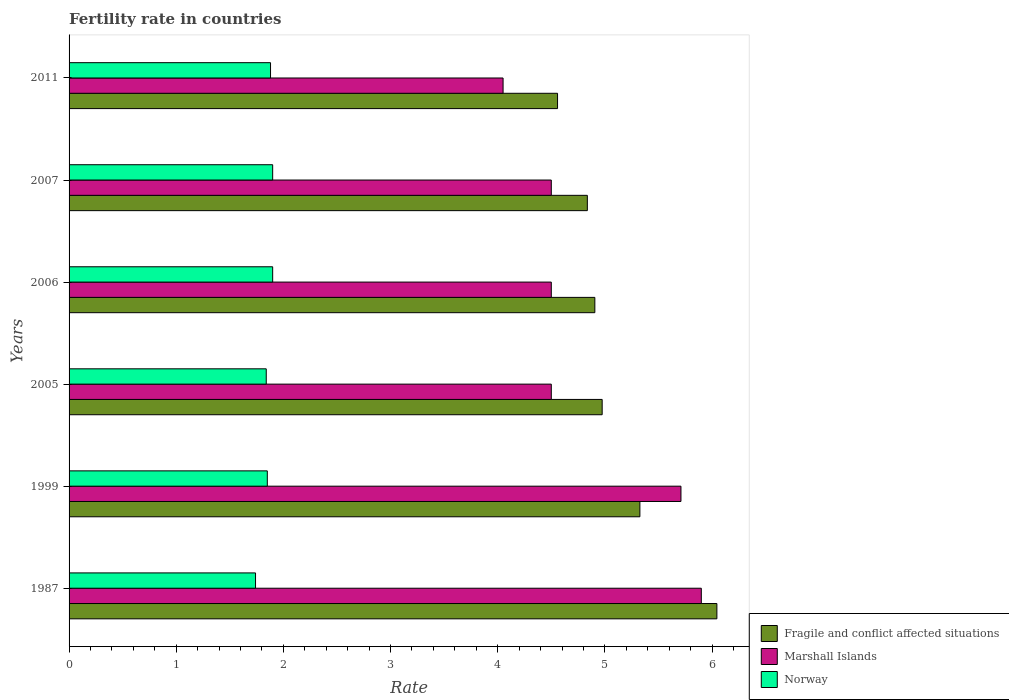How many different coloured bars are there?
Keep it short and to the point. 3. How many bars are there on the 4th tick from the bottom?
Offer a very short reply. 3. What is the label of the 3rd group of bars from the top?
Give a very brief answer. 2006. What is the fertility rate in Fragile and conflict affected situations in 2011?
Keep it short and to the point. 4.56. Across all years, what is the maximum fertility rate in Fragile and conflict affected situations?
Give a very brief answer. 6.05. Across all years, what is the minimum fertility rate in Norway?
Your answer should be very brief. 1.74. In which year was the fertility rate in Fragile and conflict affected situations maximum?
Your response must be concise. 1987. In which year was the fertility rate in Fragile and conflict affected situations minimum?
Your response must be concise. 2011. What is the total fertility rate in Norway in the graph?
Provide a succinct answer. 11.11. What is the difference between the fertility rate in Marshall Islands in 1999 and that in 2005?
Offer a very short reply. 1.21. What is the difference between the fertility rate in Norway in 2006 and the fertility rate in Marshall Islands in 2011?
Give a very brief answer. -2.15. What is the average fertility rate in Fragile and conflict affected situations per year?
Your answer should be compact. 5.11. In the year 2005, what is the difference between the fertility rate in Norway and fertility rate in Marshall Islands?
Offer a terse response. -2.66. In how many years, is the fertility rate in Marshall Islands greater than 0.4 ?
Offer a terse response. 6. What is the ratio of the fertility rate in Fragile and conflict affected situations in 1987 to that in 2011?
Ensure brevity in your answer.  1.33. Is the difference between the fertility rate in Norway in 1987 and 2007 greater than the difference between the fertility rate in Marshall Islands in 1987 and 2007?
Provide a succinct answer. No. What is the difference between the highest and the second highest fertility rate in Marshall Islands?
Your answer should be compact. 0.19. What is the difference between the highest and the lowest fertility rate in Marshall Islands?
Make the answer very short. 1.85. In how many years, is the fertility rate in Fragile and conflict affected situations greater than the average fertility rate in Fragile and conflict affected situations taken over all years?
Offer a terse response. 2. What does the 3rd bar from the top in 1999 represents?
Offer a terse response. Fragile and conflict affected situations. What does the 2nd bar from the bottom in 2006 represents?
Provide a short and direct response. Marshall Islands. How many bars are there?
Your answer should be compact. 18. How many years are there in the graph?
Offer a terse response. 6. What is the difference between two consecutive major ticks on the X-axis?
Your answer should be very brief. 1. Are the values on the major ticks of X-axis written in scientific E-notation?
Offer a terse response. No. Does the graph contain grids?
Keep it short and to the point. No. What is the title of the graph?
Keep it short and to the point. Fertility rate in countries. Does "Ireland" appear as one of the legend labels in the graph?
Give a very brief answer. No. What is the label or title of the X-axis?
Ensure brevity in your answer.  Rate. What is the label or title of the Y-axis?
Ensure brevity in your answer.  Years. What is the Rate in Fragile and conflict affected situations in 1987?
Your response must be concise. 6.05. What is the Rate of Marshall Islands in 1987?
Keep it short and to the point. 5.9. What is the Rate of Norway in 1987?
Make the answer very short. 1.74. What is the Rate in Fragile and conflict affected situations in 1999?
Make the answer very short. 5.33. What is the Rate in Marshall Islands in 1999?
Give a very brief answer. 5.71. What is the Rate of Norway in 1999?
Your answer should be very brief. 1.85. What is the Rate of Fragile and conflict affected situations in 2005?
Provide a short and direct response. 4.97. What is the Rate in Marshall Islands in 2005?
Give a very brief answer. 4.5. What is the Rate in Norway in 2005?
Your answer should be compact. 1.84. What is the Rate in Fragile and conflict affected situations in 2006?
Your answer should be very brief. 4.91. What is the Rate in Norway in 2006?
Make the answer very short. 1.9. What is the Rate in Fragile and conflict affected situations in 2007?
Offer a very short reply. 4.84. What is the Rate in Marshall Islands in 2007?
Offer a very short reply. 4.5. What is the Rate in Norway in 2007?
Your answer should be compact. 1.9. What is the Rate of Fragile and conflict affected situations in 2011?
Offer a very short reply. 4.56. What is the Rate in Marshall Islands in 2011?
Your response must be concise. 4.05. What is the Rate of Norway in 2011?
Keep it short and to the point. 1.88. Across all years, what is the maximum Rate in Fragile and conflict affected situations?
Provide a succinct answer. 6.05. Across all years, what is the minimum Rate in Fragile and conflict affected situations?
Give a very brief answer. 4.56. Across all years, what is the minimum Rate of Marshall Islands?
Provide a short and direct response. 4.05. Across all years, what is the minimum Rate in Norway?
Your answer should be compact. 1.74. What is the total Rate in Fragile and conflict affected situations in the graph?
Your response must be concise. 30.65. What is the total Rate of Marshall Islands in the graph?
Offer a terse response. 29.16. What is the total Rate in Norway in the graph?
Make the answer very short. 11.11. What is the difference between the Rate of Fragile and conflict affected situations in 1987 and that in 1999?
Your response must be concise. 0.72. What is the difference between the Rate in Marshall Islands in 1987 and that in 1999?
Your answer should be very brief. 0.19. What is the difference between the Rate of Norway in 1987 and that in 1999?
Your answer should be compact. -0.11. What is the difference between the Rate in Fragile and conflict affected situations in 1987 and that in 2005?
Make the answer very short. 1.07. What is the difference between the Rate of Fragile and conflict affected situations in 1987 and that in 2006?
Offer a very short reply. 1.14. What is the difference between the Rate in Norway in 1987 and that in 2006?
Offer a terse response. -0.16. What is the difference between the Rate in Fragile and conflict affected situations in 1987 and that in 2007?
Your answer should be compact. 1.21. What is the difference between the Rate of Marshall Islands in 1987 and that in 2007?
Your answer should be very brief. 1.4. What is the difference between the Rate of Norway in 1987 and that in 2007?
Make the answer very short. -0.16. What is the difference between the Rate of Fragile and conflict affected situations in 1987 and that in 2011?
Your answer should be compact. 1.49. What is the difference between the Rate in Marshall Islands in 1987 and that in 2011?
Provide a short and direct response. 1.85. What is the difference between the Rate in Norway in 1987 and that in 2011?
Make the answer very short. -0.14. What is the difference between the Rate in Fragile and conflict affected situations in 1999 and that in 2005?
Provide a succinct answer. 0.35. What is the difference between the Rate of Marshall Islands in 1999 and that in 2005?
Your answer should be compact. 1.21. What is the difference between the Rate in Norway in 1999 and that in 2005?
Give a very brief answer. 0.01. What is the difference between the Rate of Fragile and conflict affected situations in 1999 and that in 2006?
Offer a terse response. 0.42. What is the difference between the Rate of Marshall Islands in 1999 and that in 2006?
Keep it short and to the point. 1.21. What is the difference between the Rate of Norway in 1999 and that in 2006?
Make the answer very short. -0.05. What is the difference between the Rate of Fragile and conflict affected situations in 1999 and that in 2007?
Make the answer very short. 0.49. What is the difference between the Rate of Marshall Islands in 1999 and that in 2007?
Provide a short and direct response. 1.21. What is the difference between the Rate in Norway in 1999 and that in 2007?
Offer a terse response. -0.05. What is the difference between the Rate of Fragile and conflict affected situations in 1999 and that in 2011?
Offer a terse response. 0.77. What is the difference between the Rate of Marshall Islands in 1999 and that in 2011?
Your answer should be compact. 1.66. What is the difference between the Rate of Norway in 1999 and that in 2011?
Make the answer very short. -0.03. What is the difference between the Rate of Fragile and conflict affected situations in 2005 and that in 2006?
Offer a very short reply. 0.07. What is the difference between the Rate in Marshall Islands in 2005 and that in 2006?
Provide a short and direct response. 0. What is the difference between the Rate in Norway in 2005 and that in 2006?
Your answer should be compact. -0.06. What is the difference between the Rate in Fragile and conflict affected situations in 2005 and that in 2007?
Your answer should be compact. 0.14. What is the difference between the Rate of Marshall Islands in 2005 and that in 2007?
Make the answer very short. 0. What is the difference between the Rate of Norway in 2005 and that in 2007?
Make the answer very short. -0.06. What is the difference between the Rate in Fragile and conflict affected situations in 2005 and that in 2011?
Offer a terse response. 0.42. What is the difference between the Rate in Marshall Islands in 2005 and that in 2011?
Give a very brief answer. 0.45. What is the difference between the Rate of Norway in 2005 and that in 2011?
Give a very brief answer. -0.04. What is the difference between the Rate of Fragile and conflict affected situations in 2006 and that in 2007?
Offer a terse response. 0.07. What is the difference between the Rate of Fragile and conflict affected situations in 2006 and that in 2011?
Provide a succinct answer. 0.35. What is the difference between the Rate in Marshall Islands in 2006 and that in 2011?
Keep it short and to the point. 0.45. What is the difference between the Rate in Norway in 2006 and that in 2011?
Keep it short and to the point. 0.02. What is the difference between the Rate in Fragile and conflict affected situations in 2007 and that in 2011?
Your answer should be compact. 0.28. What is the difference between the Rate in Marshall Islands in 2007 and that in 2011?
Ensure brevity in your answer.  0.45. What is the difference between the Rate in Fragile and conflict affected situations in 1987 and the Rate in Marshall Islands in 1999?
Make the answer very short. 0.34. What is the difference between the Rate of Fragile and conflict affected situations in 1987 and the Rate of Norway in 1999?
Make the answer very short. 4.2. What is the difference between the Rate of Marshall Islands in 1987 and the Rate of Norway in 1999?
Keep it short and to the point. 4.05. What is the difference between the Rate in Fragile and conflict affected situations in 1987 and the Rate in Marshall Islands in 2005?
Offer a very short reply. 1.55. What is the difference between the Rate of Fragile and conflict affected situations in 1987 and the Rate of Norway in 2005?
Your answer should be very brief. 4.21. What is the difference between the Rate of Marshall Islands in 1987 and the Rate of Norway in 2005?
Your answer should be very brief. 4.06. What is the difference between the Rate of Fragile and conflict affected situations in 1987 and the Rate of Marshall Islands in 2006?
Offer a terse response. 1.55. What is the difference between the Rate of Fragile and conflict affected situations in 1987 and the Rate of Norway in 2006?
Provide a short and direct response. 4.15. What is the difference between the Rate of Marshall Islands in 1987 and the Rate of Norway in 2006?
Give a very brief answer. 4. What is the difference between the Rate of Fragile and conflict affected situations in 1987 and the Rate of Marshall Islands in 2007?
Offer a very short reply. 1.55. What is the difference between the Rate of Fragile and conflict affected situations in 1987 and the Rate of Norway in 2007?
Give a very brief answer. 4.15. What is the difference between the Rate in Fragile and conflict affected situations in 1987 and the Rate in Marshall Islands in 2011?
Offer a very short reply. 2. What is the difference between the Rate of Fragile and conflict affected situations in 1987 and the Rate of Norway in 2011?
Your answer should be compact. 4.17. What is the difference between the Rate of Marshall Islands in 1987 and the Rate of Norway in 2011?
Your answer should be very brief. 4.02. What is the difference between the Rate in Fragile and conflict affected situations in 1999 and the Rate in Marshall Islands in 2005?
Provide a succinct answer. 0.83. What is the difference between the Rate in Fragile and conflict affected situations in 1999 and the Rate in Norway in 2005?
Give a very brief answer. 3.49. What is the difference between the Rate of Marshall Islands in 1999 and the Rate of Norway in 2005?
Ensure brevity in your answer.  3.87. What is the difference between the Rate in Fragile and conflict affected situations in 1999 and the Rate in Marshall Islands in 2006?
Your answer should be very brief. 0.83. What is the difference between the Rate in Fragile and conflict affected situations in 1999 and the Rate in Norway in 2006?
Provide a short and direct response. 3.43. What is the difference between the Rate in Marshall Islands in 1999 and the Rate in Norway in 2006?
Offer a very short reply. 3.81. What is the difference between the Rate of Fragile and conflict affected situations in 1999 and the Rate of Marshall Islands in 2007?
Provide a short and direct response. 0.83. What is the difference between the Rate of Fragile and conflict affected situations in 1999 and the Rate of Norway in 2007?
Provide a succinct answer. 3.43. What is the difference between the Rate in Marshall Islands in 1999 and the Rate in Norway in 2007?
Keep it short and to the point. 3.81. What is the difference between the Rate of Fragile and conflict affected situations in 1999 and the Rate of Marshall Islands in 2011?
Give a very brief answer. 1.28. What is the difference between the Rate of Fragile and conflict affected situations in 1999 and the Rate of Norway in 2011?
Ensure brevity in your answer.  3.45. What is the difference between the Rate of Marshall Islands in 1999 and the Rate of Norway in 2011?
Your answer should be compact. 3.83. What is the difference between the Rate in Fragile and conflict affected situations in 2005 and the Rate in Marshall Islands in 2006?
Keep it short and to the point. 0.47. What is the difference between the Rate of Fragile and conflict affected situations in 2005 and the Rate of Norway in 2006?
Provide a succinct answer. 3.07. What is the difference between the Rate in Fragile and conflict affected situations in 2005 and the Rate in Marshall Islands in 2007?
Provide a short and direct response. 0.47. What is the difference between the Rate of Fragile and conflict affected situations in 2005 and the Rate of Norway in 2007?
Make the answer very short. 3.07. What is the difference between the Rate in Marshall Islands in 2005 and the Rate in Norway in 2007?
Your answer should be compact. 2.6. What is the difference between the Rate in Fragile and conflict affected situations in 2005 and the Rate in Marshall Islands in 2011?
Your answer should be compact. 0.92. What is the difference between the Rate in Fragile and conflict affected situations in 2005 and the Rate in Norway in 2011?
Keep it short and to the point. 3.09. What is the difference between the Rate in Marshall Islands in 2005 and the Rate in Norway in 2011?
Offer a very short reply. 2.62. What is the difference between the Rate in Fragile and conflict affected situations in 2006 and the Rate in Marshall Islands in 2007?
Keep it short and to the point. 0.41. What is the difference between the Rate of Fragile and conflict affected situations in 2006 and the Rate of Norway in 2007?
Provide a succinct answer. 3.01. What is the difference between the Rate of Fragile and conflict affected situations in 2006 and the Rate of Marshall Islands in 2011?
Offer a very short reply. 0.86. What is the difference between the Rate in Fragile and conflict affected situations in 2006 and the Rate in Norway in 2011?
Keep it short and to the point. 3.03. What is the difference between the Rate of Marshall Islands in 2006 and the Rate of Norway in 2011?
Ensure brevity in your answer.  2.62. What is the difference between the Rate in Fragile and conflict affected situations in 2007 and the Rate in Marshall Islands in 2011?
Give a very brief answer. 0.79. What is the difference between the Rate in Fragile and conflict affected situations in 2007 and the Rate in Norway in 2011?
Keep it short and to the point. 2.96. What is the difference between the Rate in Marshall Islands in 2007 and the Rate in Norway in 2011?
Your response must be concise. 2.62. What is the average Rate of Fragile and conflict affected situations per year?
Offer a terse response. 5.11. What is the average Rate of Marshall Islands per year?
Make the answer very short. 4.86. What is the average Rate in Norway per year?
Ensure brevity in your answer.  1.85. In the year 1987, what is the difference between the Rate of Fragile and conflict affected situations and Rate of Marshall Islands?
Your answer should be compact. 0.15. In the year 1987, what is the difference between the Rate of Fragile and conflict affected situations and Rate of Norway?
Keep it short and to the point. 4.31. In the year 1987, what is the difference between the Rate in Marshall Islands and Rate in Norway?
Your answer should be very brief. 4.16. In the year 1999, what is the difference between the Rate in Fragile and conflict affected situations and Rate in Marshall Islands?
Your answer should be compact. -0.38. In the year 1999, what is the difference between the Rate in Fragile and conflict affected situations and Rate in Norway?
Your answer should be compact. 3.48. In the year 1999, what is the difference between the Rate in Marshall Islands and Rate in Norway?
Your answer should be compact. 3.86. In the year 2005, what is the difference between the Rate in Fragile and conflict affected situations and Rate in Marshall Islands?
Your response must be concise. 0.47. In the year 2005, what is the difference between the Rate in Fragile and conflict affected situations and Rate in Norway?
Offer a very short reply. 3.13. In the year 2005, what is the difference between the Rate in Marshall Islands and Rate in Norway?
Offer a terse response. 2.66. In the year 2006, what is the difference between the Rate in Fragile and conflict affected situations and Rate in Marshall Islands?
Ensure brevity in your answer.  0.41. In the year 2006, what is the difference between the Rate of Fragile and conflict affected situations and Rate of Norway?
Your response must be concise. 3.01. In the year 2006, what is the difference between the Rate in Marshall Islands and Rate in Norway?
Provide a short and direct response. 2.6. In the year 2007, what is the difference between the Rate in Fragile and conflict affected situations and Rate in Marshall Islands?
Offer a very short reply. 0.34. In the year 2007, what is the difference between the Rate of Fragile and conflict affected situations and Rate of Norway?
Give a very brief answer. 2.94. In the year 2007, what is the difference between the Rate in Marshall Islands and Rate in Norway?
Make the answer very short. 2.6. In the year 2011, what is the difference between the Rate in Fragile and conflict affected situations and Rate in Marshall Islands?
Your response must be concise. 0.51. In the year 2011, what is the difference between the Rate in Fragile and conflict affected situations and Rate in Norway?
Your response must be concise. 2.68. In the year 2011, what is the difference between the Rate in Marshall Islands and Rate in Norway?
Your response must be concise. 2.17. What is the ratio of the Rate of Fragile and conflict affected situations in 1987 to that in 1999?
Your response must be concise. 1.13. What is the ratio of the Rate of Marshall Islands in 1987 to that in 1999?
Your answer should be compact. 1.03. What is the ratio of the Rate in Norway in 1987 to that in 1999?
Provide a short and direct response. 0.94. What is the ratio of the Rate of Fragile and conflict affected situations in 1987 to that in 2005?
Keep it short and to the point. 1.22. What is the ratio of the Rate in Marshall Islands in 1987 to that in 2005?
Make the answer very short. 1.31. What is the ratio of the Rate of Norway in 1987 to that in 2005?
Provide a short and direct response. 0.95. What is the ratio of the Rate in Fragile and conflict affected situations in 1987 to that in 2006?
Keep it short and to the point. 1.23. What is the ratio of the Rate in Marshall Islands in 1987 to that in 2006?
Your answer should be compact. 1.31. What is the ratio of the Rate of Norway in 1987 to that in 2006?
Make the answer very short. 0.92. What is the ratio of the Rate in Fragile and conflict affected situations in 1987 to that in 2007?
Provide a succinct answer. 1.25. What is the ratio of the Rate in Marshall Islands in 1987 to that in 2007?
Ensure brevity in your answer.  1.31. What is the ratio of the Rate of Norway in 1987 to that in 2007?
Your response must be concise. 0.92. What is the ratio of the Rate in Fragile and conflict affected situations in 1987 to that in 2011?
Provide a succinct answer. 1.33. What is the ratio of the Rate of Marshall Islands in 1987 to that in 2011?
Make the answer very short. 1.46. What is the ratio of the Rate in Norway in 1987 to that in 2011?
Make the answer very short. 0.93. What is the ratio of the Rate in Fragile and conflict affected situations in 1999 to that in 2005?
Offer a terse response. 1.07. What is the ratio of the Rate of Marshall Islands in 1999 to that in 2005?
Make the answer very short. 1.27. What is the ratio of the Rate of Norway in 1999 to that in 2005?
Provide a short and direct response. 1.01. What is the ratio of the Rate of Fragile and conflict affected situations in 1999 to that in 2006?
Your answer should be very brief. 1.09. What is the ratio of the Rate in Marshall Islands in 1999 to that in 2006?
Your answer should be very brief. 1.27. What is the ratio of the Rate in Norway in 1999 to that in 2006?
Provide a short and direct response. 0.97. What is the ratio of the Rate in Fragile and conflict affected situations in 1999 to that in 2007?
Ensure brevity in your answer.  1.1. What is the ratio of the Rate of Marshall Islands in 1999 to that in 2007?
Make the answer very short. 1.27. What is the ratio of the Rate in Norway in 1999 to that in 2007?
Make the answer very short. 0.97. What is the ratio of the Rate in Fragile and conflict affected situations in 1999 to that in 2011?
Provide a succinct answer. 1.17. What is the ratio of the Rate of Marshall Islands in 1999 to that in 2011?
Offer a terse response. 1.41. What is the ratio of the Rate of Fragile and conflict affected situations in 2005 to that in 2006?
Make the answer very short. 1.01. What is the ratio of the Rate of Marshall Islands in 2005 to that in 2006?
Ensure brevity in your answer.  1. What is the ratio of the Rate in Norway in 2005 to that in 2006?
Your response must be concise. 0.97. What is the ratio of the Rate in Fragile and conflict affected situations in 2005 to that in 2007?
Your answer should be compact. 1.03. What is the ratio of the Rate of Norway in 2005 to that in 2007?
Keep it short and to the point. 0.97. What is the ratio of the Rate in Fragile and conflict affected situations in 2005 to that in 2011?
Offer a very short reply. 1.09. What is the ratio of the Rate of Norway in 2005 to that in 2011?
Give a very brief answer. 0.98. What is the ratio of the Rate in Fragile and conflict affected situations in 2006 to that in 2007?
Ensure brevity in your answer.  1.01. What is the ratio of the Rate of Norway in 2006 to that in 2007?
Keep it short and to the point. 1. What is the ratio of the Rate in Fragile and conflict affected situations in 2006 to that in 2011?
Provide a succinct answer. 1.08. What is the ratio of the Rate in Marshall Islands in 2006 to that in 2011?
Provide a succinct answer. 1.11. What is the ratio of the Rate in Norway in 2006 to that in 2011?
Give a very brief answer. 1.01. What is the ratio of the Rate of Fragile and conflict affected situations in 2007 to that in 2011?
Your answer should be compact. 1.06. What is the ratio of the Rate in Norway in 2007 to that in 2011?
Provide a short and direct response. 1.01. What is the difference between the highest and the second highest Rate in Fragile and conflict affected situations?
Your answer should be compact. 0.72. What is the difference between the highest and the second highest Rate of Marshall Islands?
Make the answer very short. 0.19. What is the difference between the highest and the lowest Rate of Fragile and conflict affected situations?
Keep it short and to the point. 1.49. What is the difference between the highest and the lowest Rate in Marshall Islands?
Your answer should be very brief. 1.85. What is the difference between the highest and the lowest Rate of Norway?
Keep it short and to the point. 0.16. 